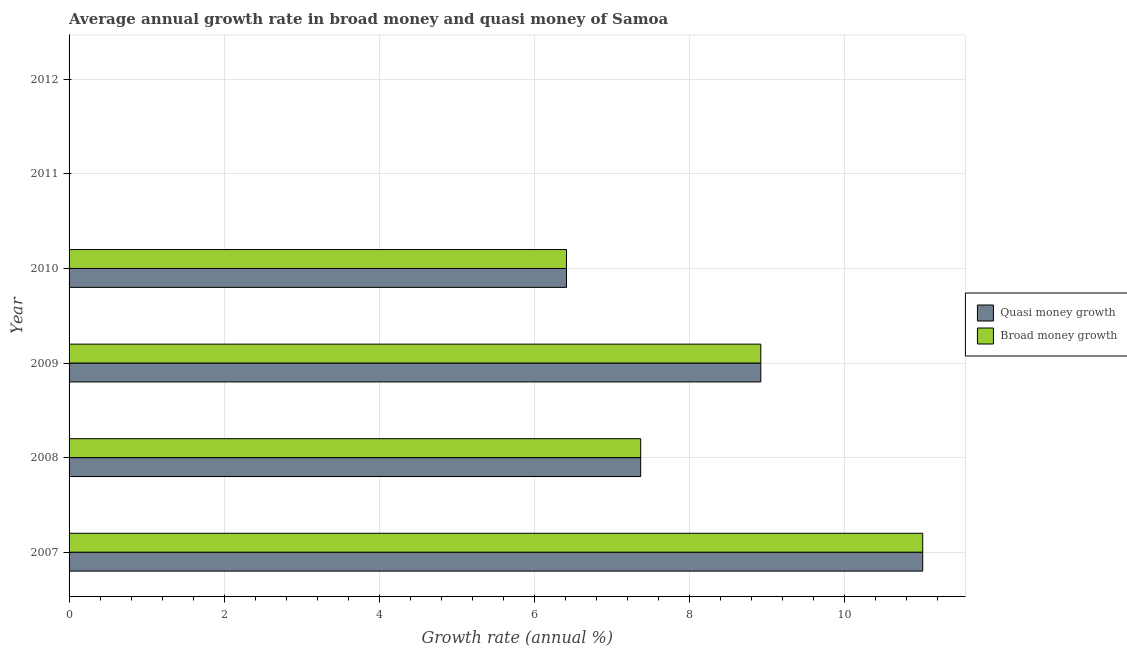How many different coloured bars are there?
Give a very brief answer. 2. Are the number of bars on each tick of the Y-axis equal?
Your answer should be very brief. No. How many bars are there on the 2nd tick from the top?
Give a very brief answer. 0. How many bars are there on the 6th tick from the bottom?
Provide a succinct answer. 0. What is the annual growth rate in broad money in 2008?
Ensure brevity in your answer.  7.37. Across all years, what is the maximum annual growth rate in broad money?
Your answer should be compact. 11.01. Across all years, what is the minimum annual growth rate in quasi money?
Offer a very short reply. 0. In which year was the annual growth rate in quasi money maximum?
Provide a succinct answer. 2007. What is the total annual growth rate in quasi money in the graph?
Provide a short and direct response. 33.71. What is the difference between the annual growth rate in broad money in 2011 and the annual growth rate in quasi money in 2007?
Keep it short and to the point. -11.01. What is the average annual growth rate in broad money per year?
Keep it short and to the point. 5.62. What is the ratio of the annual growth rate in broad money in 2007 to that in 2008?
Offer a very short reply. 1.49. What is the difference between the highest and the second highest annual growth rate in quasi money?
Your answer should be very brief. 2.09. What is the difference between the highest and the lowest annual growth rate in broad money?
Ensure brevity in your answer.  11.01. In how many years, is the annual growth rate in broad money greater than the average annual growth rate in broad money taken over all years?
Offer a terse response. 4. Are all the bars in the graph horizontal?
Your answer should be very brief. Yes. How many years are there in the graph?
Make the answer very short. 6. Does the graph contain grids?
Your response must be concise. Yes. Where does the legend appear in the graph?
Your answer should be very brief. Center right. What is the title of the graph?
Keep it short and to the point. Average annual growth rate in broad money and quasi money of Samoa. What is the label or title of the X-axis?
Provide a short and direct response. Growth rate (annual %). What is the label or title of the Y-axis?
Provide a succinct answer. Year. What is the Growth rate (annual %) in Quasi money growth in 2007?
Your answer should be compact. 11.01. What is the Growth rate (annual %) in Broad money growth in 2007?
Make the answer very short. 11.01. What is the Growth rate (annual %) in Quasi money growth in 2008?
Provide a short and direct response. 7.37. What is the Growth rate (annual %) in Broad money growth in 2008?
Give a very brief answer. 7.37. What is the Growth rate (annual %) in Quasi money growth in 2009?
Ensure brevity in your answer.  8.92. What is the Growth rate (annual %) in Broad money growth in 2009?
Make the answer very short. 8.92. What is the Growth rate (annual %) of Quasi money growth in 2010?
Make the answer very short. 6.41. What is the Growth rate (annual %) of Broad money growth in 2010?
Offer a very short reply. 6.41. What is the Growth rate (annual %) of Quasi money growth in 2011?
Provide a succinct answer. 0. What is the Growth rate (annual %) in Quasi money growth in 2012?
Make the answer very short. 0. Across all years, what is the maximum Growth rate (annual %) in Quasi money growth?
Your response must be concise. 11.01. Across all years, what is the maximum Growth rate (annual %) of Broad money growth?
Provide a succinct answer. 11.01. Across all years, what is the minimum Growth rate (annual %) in Broad money growth?
Make the answer very short. 0. What is the total Growth rate (annual %) of Quasi money growth in the graph?
Give a very brief answer. 33.71. What is the total Growth rate (annual %) in Broad money growth in the graph?
Make the answer very short. 33.71. What is the difference between the Growth rate (annual %) of Quasi money growth in 2007 and that in 2008?
Offer a terse response. 3.64. What is the difference between the Growth rate (annual %) of Broad money growth in 2007 and that in 2008?
Provide a short and direct response. 3.64. What is the difference between the Growth rate (annual %) of Quasi money growth in 2007 and that in 2009?
Keep it short and to the point. 2.09. What is the difference between the Growth rate (annual %) in Broad money growth in 2007 and that in 2009?
Your answer should be very brief. 2.09. What is the difference between the Growth rate (annual %) of Quasi money growth in 2007 and that in 2010?
Your answer should be very brief. 4.59. What is the difference between the Growth rate (annual %) in Broad money growth in 2007 and that in 2010?
Give a very brief answer. 4.59. What is the difference between the Growth rate (annual %) in Quasi money growth in 2008 and that in 2009?
Your answer should be very brief. -1.55. What is the difference between the Growth rate (annual %) of Broad money growth in 2008 and that in 2009?
Ensure brevity in your answer.  -1.55. What is the difference between the Growth rate (annual %) of Quasi money growth in 2008 and that in 2010?
Offer a very short reply. 0.96. What is the difference between the Growth rate (annual %) of Broad money growth in 2008 and that in 2010?
Ensure brevity in your answer.  0.96. What is the difference between the Growth rate (annual %) of Quasi money growth in 2009 and that in 2010?
Provide a short and direct response. 2.51. What is the difference between the Growth rate (annual %) in Broad money growth in 2009 and that in 2010?
Your answer should be compact. 2.51. What is the difference between the Growth rate (annual %) in Quasi money growth in 2007 and the Growth rate (annual %) in Broad money growth in 2008?
Offer a terse response. 3.64. What is the difference between the Growth rate (annual %) of Quasi money growth in 2007 and the Growth rate (annual %) of Broad money growth in 2009?
Give a very brief answer. 2.09. What is the difference between the Growth rate (annual %) in Quasi money growth in 2007 and the Growth rate (annual %) in Broad money growth in 2010?
Your response must be concise. 4.59. What is the difference between the Growth rate (annual %) of Quasi money growth in 2008 and the Growth rate (annual %) of Broad money growth in 2009?
Provide a succinct answer. -1.55. What is the difference between the Growth rate (annual %) in Quasi money growth in 2008 and the Growth rate (annual %) in Broad money growth in 2010?
Your answer should be very brief. 0.96. What is the difference between the Growth rate (annual %) of Quasi money growth in 2009 and the Growth rate (annual %) of Broad money growth in 2010?
Give a very brief answer. 2.51. What is the average Growth rate (annual %) of Quasi money growth per year?
Make the answer very short. 5.62. What is the average Growth rate (annual %) in Broad money growth per year?
Offer a terse response. 5.62. In the year 2007, what is the difference between the Growth rate (annual %) of Quasi money growth and Growth rate (annual %) of Broad money growth?
Make the answer very short. 0. In the year 2009, what is the difference between the Growth rate (annual %) in Quasi money growth and Growth rate (annual %) in Broad money growth?
Make the answer very short. 0. What is the ratio of the Growth rate (annual %) of Quasi money growth in 2007 to that in 2008?
Give a very brief answer. 1.49. What is the ratio of the Growth rate (annual %) in Broad money growth in 2007 to that in 2008?
Your answer should be very brief. 1.49. What is the ratio of the Growth rate (annual %) in Quasi money growth in 2007 to that in 2009?
Offer a terse response. 1.23. What is the ratio of the Growth rate (annual %) in Broad money growth in 2007 to that in 2009?
Offer a terse response. 1.23. What is the ratio of the Growth rate (annual %) of Quasi money growth in 2007 to that in 2010?
Keep it short and to the point. 1.72. What is the ratio of the Growth rate (annual %) of Broad money growth in 2007 to that in 2010?
Keep it short and to the point. 1.72. What is the ratio of the Growth rate (annual %) of Quasi money growth in 2008 to that in 2009?
Offer a very short reply. 0.83. What is the ratio of the Growth rate (annual %) of Broad money growth in 2008 to that in 2009?
Offer a very short reply. 0.83. What is the ratio of the Growth rate (annual %) in Quasi money growth in 2008 to that in 2010?
Keep it short and to the point. 1.15. What is the ratio of the Growth rate (annual %) of Broad money growth in 2008 to that in 2010?
Your answer should be compact. 1.15. What is the ratio of the Growth rate (annual %) in Quasi money growth in 2009 to that in 2010?
Make the answer very short. 1.39. What is the ratio of the Growth rate (annual %) of Broad money growth in 2009 to that in 2010?
Provide a succinct answer. 1.39. What is the difference between the highest and the second highest Growth rate (annual %) in Quasi money growth?
Your response must be concise. 2.09. What is the difference between the highest and the second highest Growth rate (annual %) in Broad money growth?
Provide a short and direct response. 2.09. What is the difference between the highest and the lowest Growth rate (annual %) in Quasi money growth?
Ensure brevity in your answer.  11.01. What is the difference between the highest and the lowest Growth rate (annual %) in Broad money growth?
Provide a succinct answer. 11.01. 